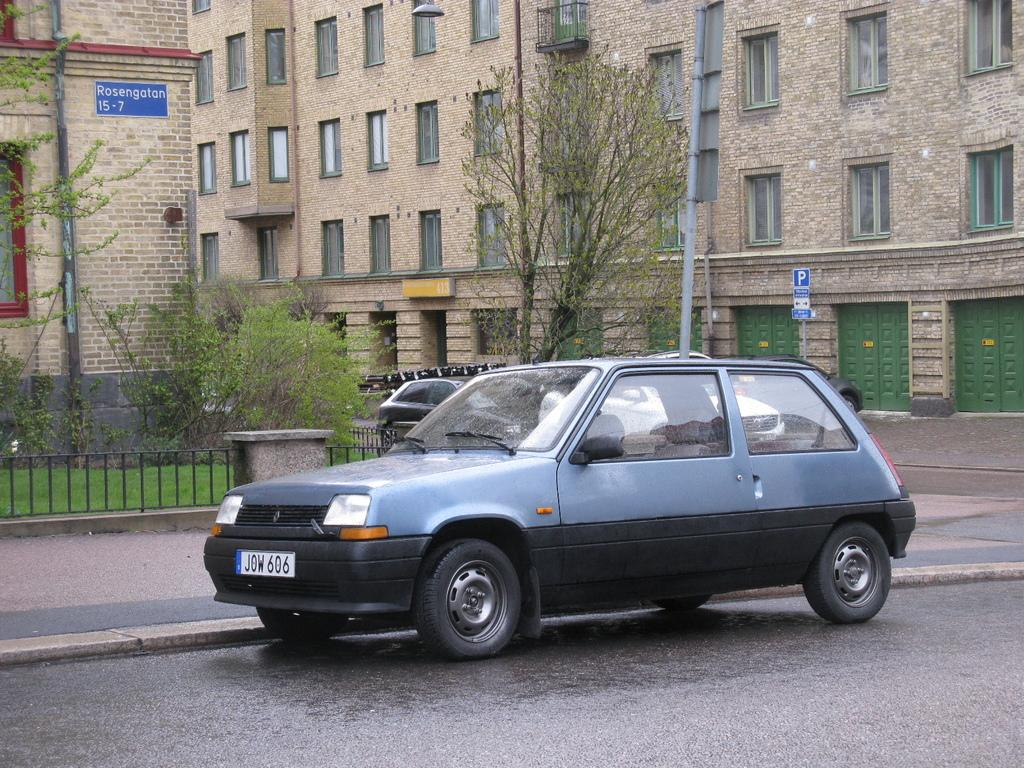What can be seen on the road in the image? There are cars on the road in the image. What type of natural elements are present in the image? There are trees in the image. How many buildings can be seen in the image? There are two buildings in the image. What type of barrier is present in the image? There is an iron railing in the image. What type of information might be conveyed by the sign board in the image? The sign board in the image might convey information about directions, warnings, or advertisements. What are the poles with boards used for in the image? The poles with boards might be used for displaying advertisements or announcements. What features do the buildings have? The buildings have windows and doors. What type of note is being passed between the cars in the image? There is no note being passed between the cars in the image. What type of lead can be seen in the image? There is no lead present in the image. What holiday is being celebrated in the image? There is no indication of a holiday being celebrated in the image. 